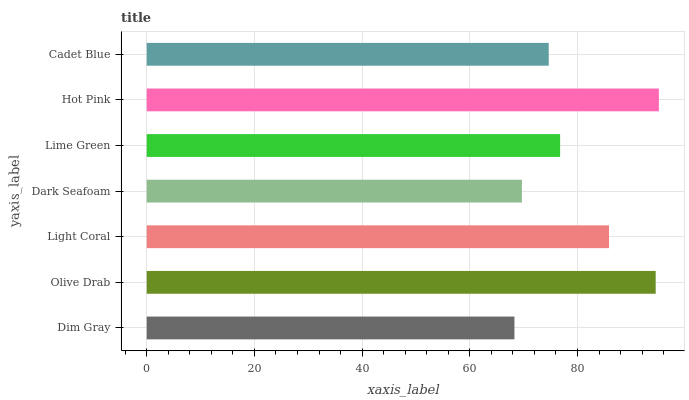Is Dim Gray the minimum?
Answer yes or no. Yes. Is Hot Pink the maximum?
Answer yes or no. Yes. Is Olive Drab the minimum?
Answer yes or no. No. Is Olive Drab the maximum?
Answer yes or no. No. Is Olive Drab greater than Dim Gray?
Answer yes or no. Yes. Is Dim Gray less than Olive Drab?
Answer yes or no. Yes. Is Dim Gray greater than Olive Drab?
Answer yes or no. No. Is Olive Drab less than Dim Gray?
Answer yes or no. No. Is Lime Green the high median?
Answer yes or no. Yes. Is Lime Green the low median?
Answer yes or no. Yes. Is Dark Seafoam the high median?
Answer yes or no. No. Is Light Coral the low median?
Answer yes or no. No. 